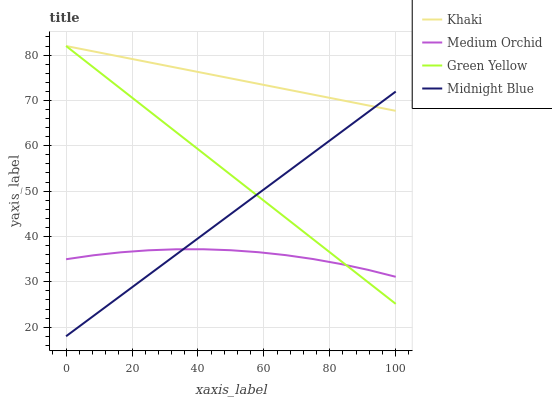Does Green Yellow have the minimum area under the curve?
Answer yes or no. No. Does Green Yellow have the maximum area under the curve?
Answer yes or no. No. Is Khaki the smoothest?
Answer yes or no. No. Is Khaki the roughest?
Answer yes or no. No. Does Green Yellow have the lowest value?
Answer yes or no. No. Does Midnight Blue have the highest value?
Answer yes or no. No. Is Medium Orchid less than Khaki?
Answer yes or no. Yes. Is Khaki greater than Medium Orchid?
Answer yes or no. Yes. Does Medium Orchid intersect Khaki?
Answer yes or no. No. 